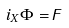<formula> <loc_0><loc_0><loc_500><loc_500>i _ { X } \Phi = \digamma</formula> 